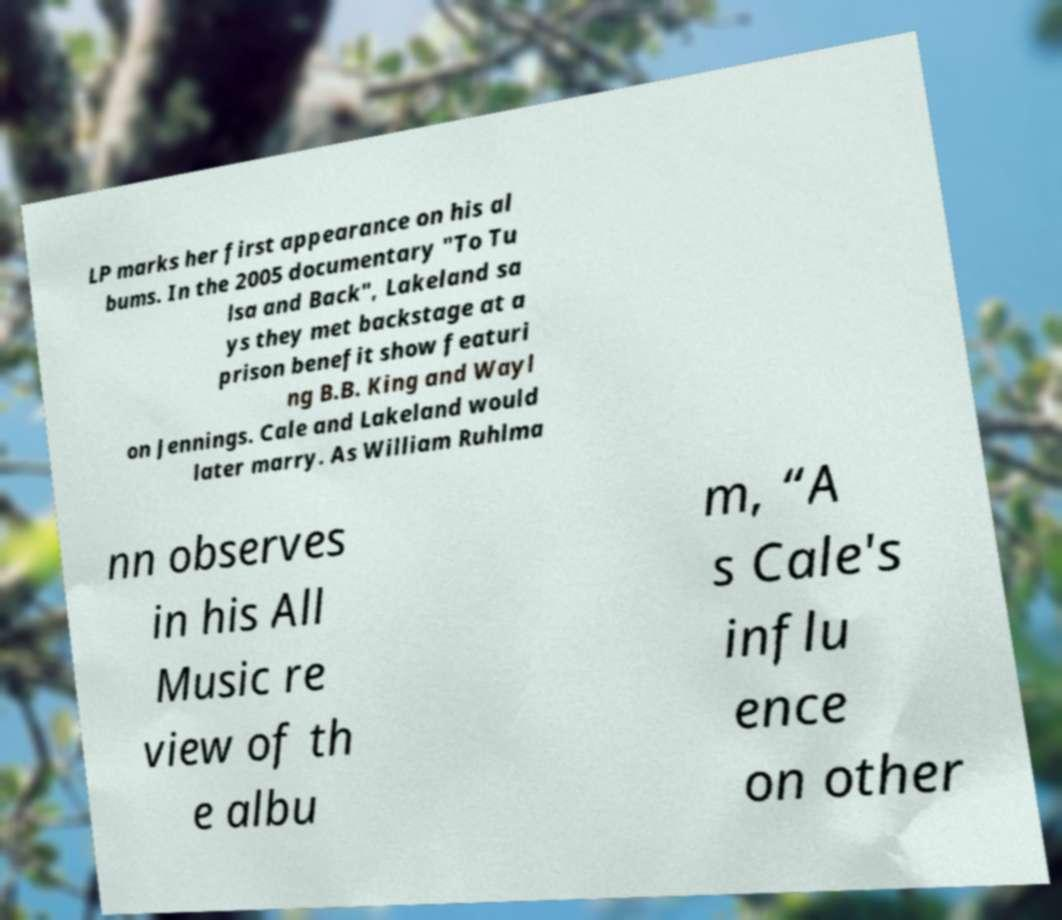Please identify and transcribe the text found in this image. LP marks her first appearance on his al bums. In the 2005 documentary "To Tu lsa and Back", Lakeland sa ys they met backstage at a prison benefit show featuri ng B.B. King and Wayl on Jennings. Cale and Lakeland would later marry. As William Ruhlma nn observes in his All Music re view of th e albu m, “A s Cale's influ ence on other 